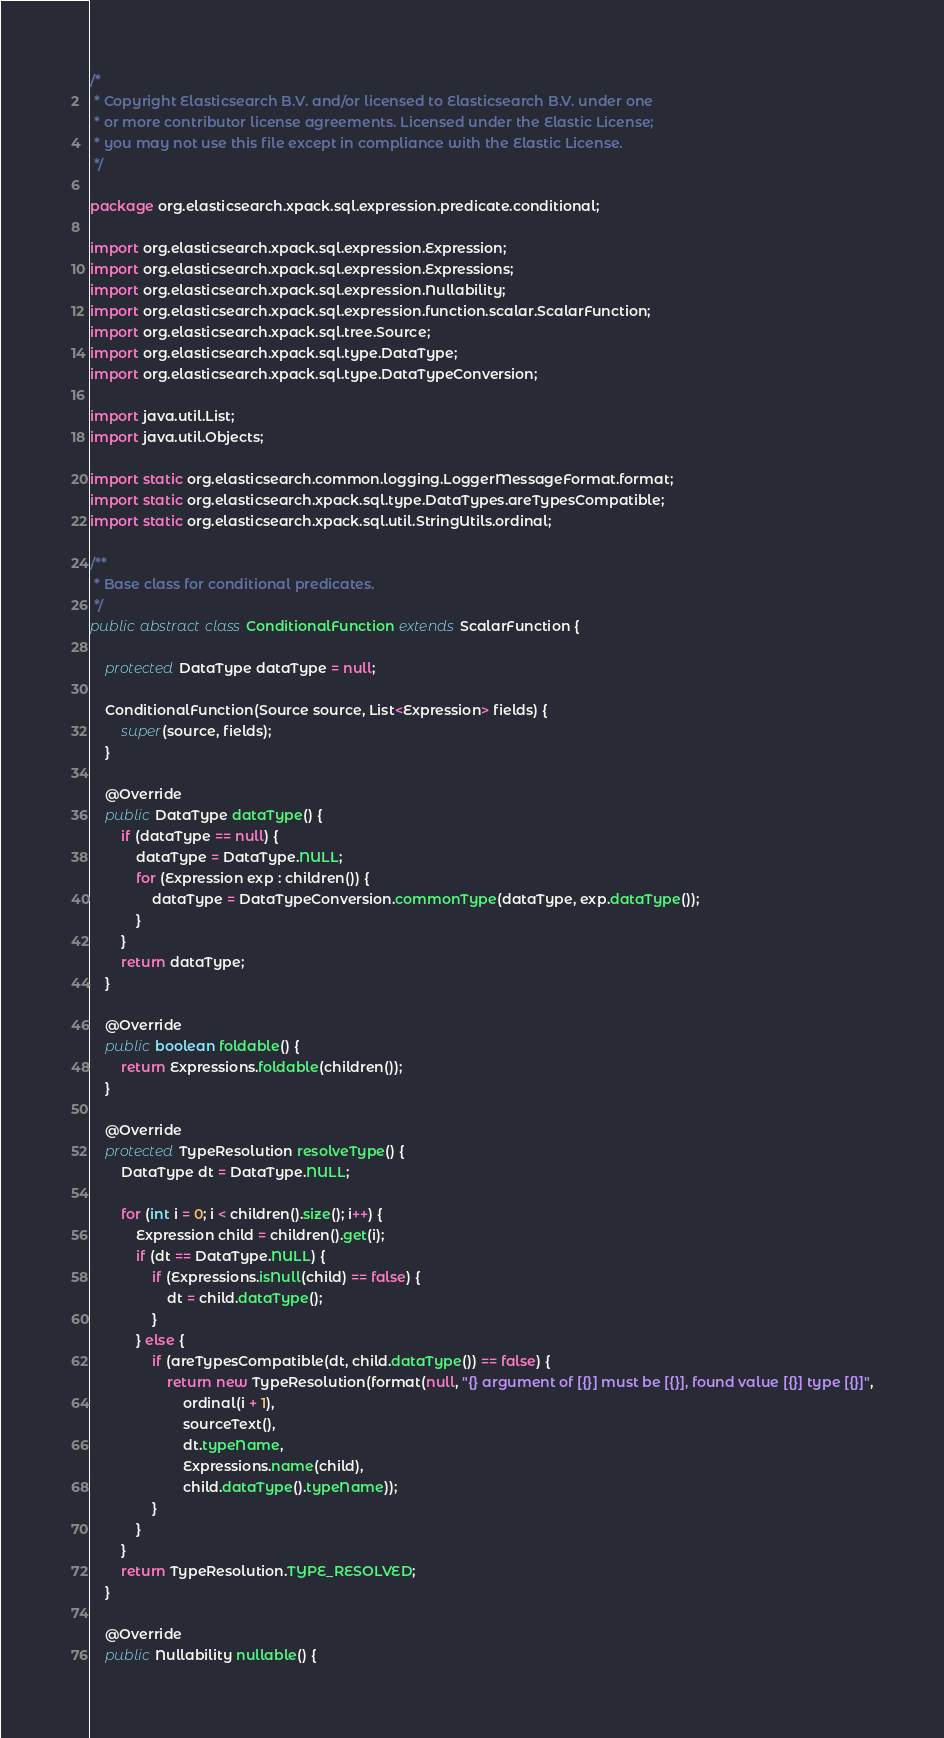Convert code to text. <code><loc_0><loc_0><loc_500><loc_500><_Java_>/*
 * Copyright Elasticsearch B.V. and/or licensed to Elasticsearch B.V. under one
 * or more contributor license agreements. Licensed under the Elastic License;
 * you may not use this file except in compliance with the Elastic License.
 */

package org.elasticsearch.xpack.sql.expression.predicate.conditional;

import org.elasticsearch.xpack.sql.expression.Expression;
import org.elasticsearch.xpack.sql.expression.Expressions;
import org.elasticsearch.xpack.sql.expression.Nullability;
import org.elasticsearch.xpack.sql.expression.function.scalar.ScalarFunction;
import org.elasticsearch.xpack.sql.tree.Source;
import org.elasticsearch.xpack.sql.type.DataType;
import org.elasticsearch.xpack.sql.type.DataTypeConversion;

import java.util.List;
import java.util.Objects;

import static org.elasticsearch.common.logging.LoggerMessageFormat.format;
import static org.elasticsearch.xpack.sql.type.DataTypes.areTypesCompatible;
import static org.elasticsearch.xpack.sql.util.StringUtils.ordinal;

/**
 * Base class for conditional predicates.
 */
public abstract class ConditionalFunction extends ScalarFunction {

    protected DataType dataType = null;

    ConditionalFunction(Source source, List<Expression> fields) {
        super(source, fields);
    }

    @Override
    public DataType dataType() {
        if (dataType == null) {
            dataType = DataType.NULL;
            for (Expression exp : children()) {
                dataType = DataTypeConversion.commonType(dataType, exp.dataType());
            }
        }
        return dataType;
    }

    @Override
    public boolean foldable() {
        return Expressions.foldable(children());
    }

    @Override
    protected TypeResolution resolveType() {
        DataType dt = DataType.NULL;

        for (int i = 0; i < children().size(); i++) {
            Expression child = children().get(i);
            if (dt == DataType.NULL) {
                if (Expressions.isNull(child) == false) {
                    dt = child.dataType();
                }
            } else {
                if (areTypesCompatible(dt, child.dataType()) == false) {
                    return new TypeResolution(format(null, "{} argument of [{}] must be [{}], found value [{}] type [{}]",
                        ordinal(i + 1),
                        sourceText(),
                        dt.typeName,
                        Expressions.name(child),
                        child.dataType().typeName));
                }
            }
        }
        return TypeResolution.TYPE_RESOLVED;
    }

    @Override
    public Nullability nullable() {</code> 